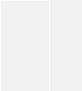<code> <loc_0><loc_0><loc_500><loc_500><_YAML_>
</code> 